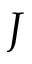<formula> <loc_0><loc_0><loc_500><loc_500>J</formula> 